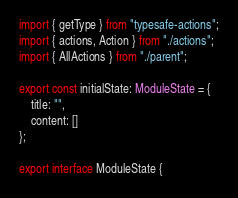Convert code to text. <code><loc_0><loc_0><loc_500><loc_500><_TypeScript_>import { getType } from "typesafe-actions";
import { actions, Action } from "./actions";
import { AllActions } from "./parent";

export const initialState: ModuleState = {
    title: "",
    content: []
};

export interface ModuleState {</code> 